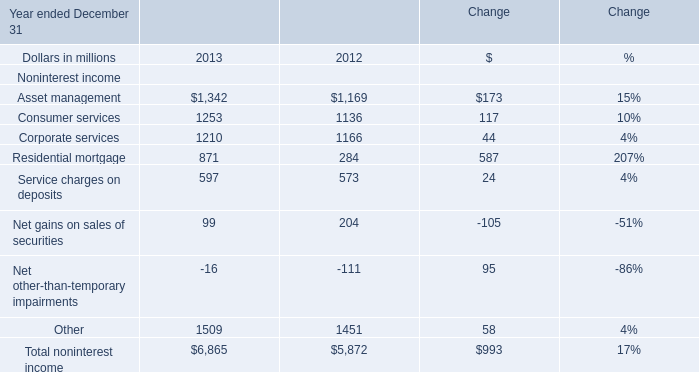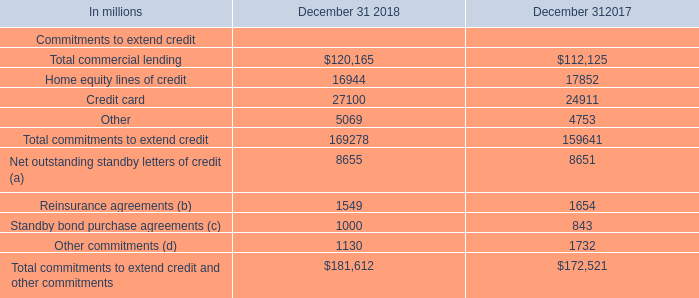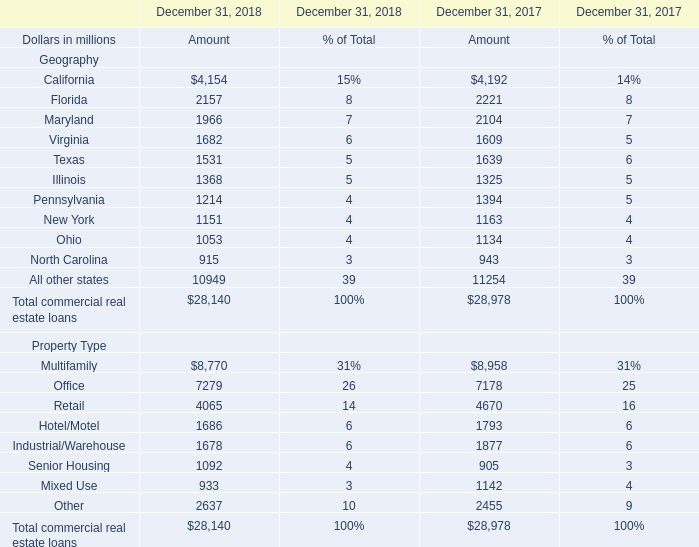What will Virginia reach in 2019 if it continues to grow at its current rate? (in million) 
Computations: (1682 * (1 + ((1682 - 1609) / 1609)))
Answer: 1758.312. 